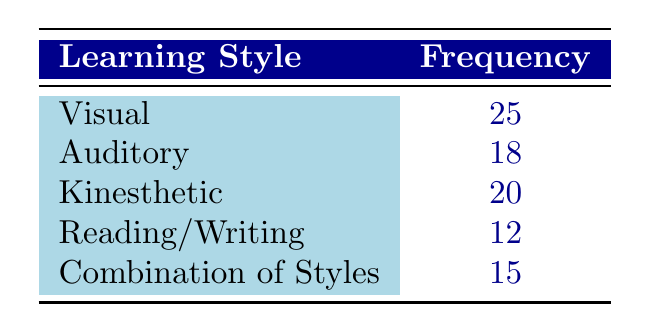What is the frequency of the Visual learning style? The table shows that the frequency for Visual learning style is directly listed as 25.
Answer: 25 What is the least frequently observed learning style among early childhood educators? By examining the frequencies in the table, Reading/Writing has the lowest frequency at 12.
Answer: Reading/Writing What is the total frequency of all learning styles combined? To find the total frequency, sum all the frequencies listed: 25 (Visual) + 18 (Auditory) + 20 (Kinesthetic) + 12 (Reading/Writing) + 15 (Combination of Styles) = 90.
Answer: 90 What is the difference in frequency between the Kinesthetic and Combination of Styles? The frequency for Kinesthetic is 20, and for Combination of Styles, it is 15. Thus, the difference is 20 - 15 = 5.
Answer: 5 Is the frequency of the Auditory learning style greater than that of the Reading/Writing style? The frequency for Auditory is 18 and for Reading/Writing is 12. Since 18 is greater than 12, the answer is yes.
Answer: Yes What is the average frequency of the learning styles? To calculate the average, sum the frequencies (90) and divide by the number of styles (5): 90 / 5 = 18.
Answer: 18 Based on the table, do more educators prefer Visual or Auditory learning styles? The frequency for Visual is 25 and for Auditory is 18. Since 25 is greater than 18, more educators prefer Visual.
Answer: Yes Which learning style has a frequency that is closest to the average frequency of the styles? The average frequency is 18, and the closest frequency to this value is 18 (Auditory) since it's equal to the average.
Answer: Auditory If you combine the frequencies of the Visual and Kinesthetic styles, what will you get? The frequency for Visual is 25 and for Kinesthetic is 20. So, adding these together gives 25 + 20 = 45.
Answer: 45 How many more educators prefer Kinesthetic learning style compared to Reading/Writing? The frequency for Kinesthetic is 20 and for Reading/Writing is 12. Subtracting gives 20 - 12 = 8.
Answer: 8 